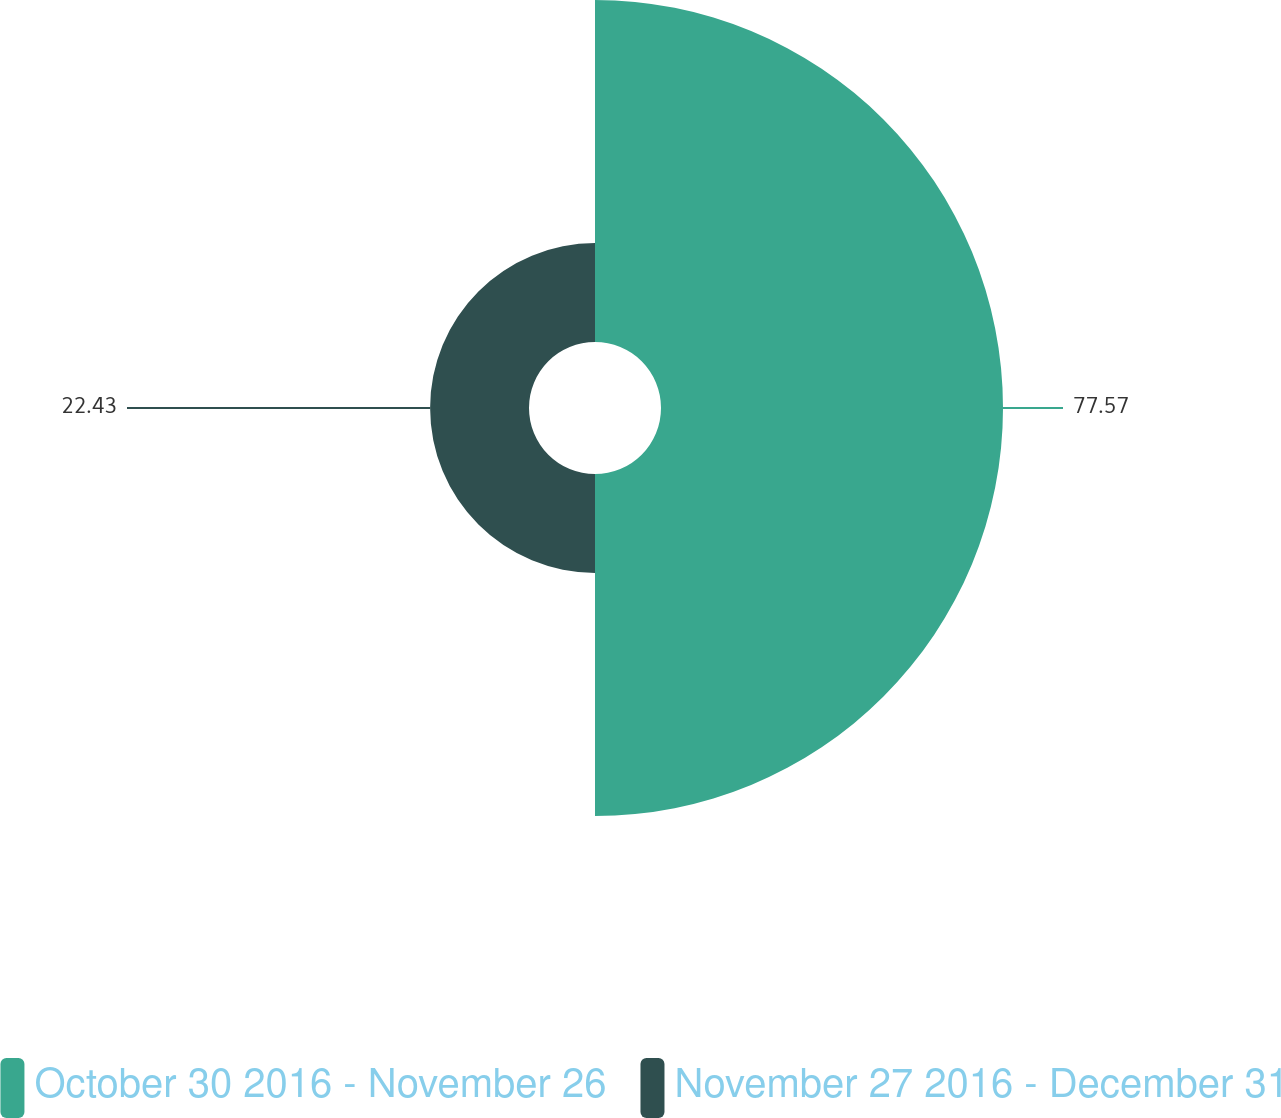Convert chart to OTSL. <chart><loc_0><loc_0><loc_500><loc_500><pie_chart><fcel>October 30 2016 - November 26<fcel>November 27 2016 - December 31<nl><fcel>77.57%<fcel>22.43%<nl></chart> 